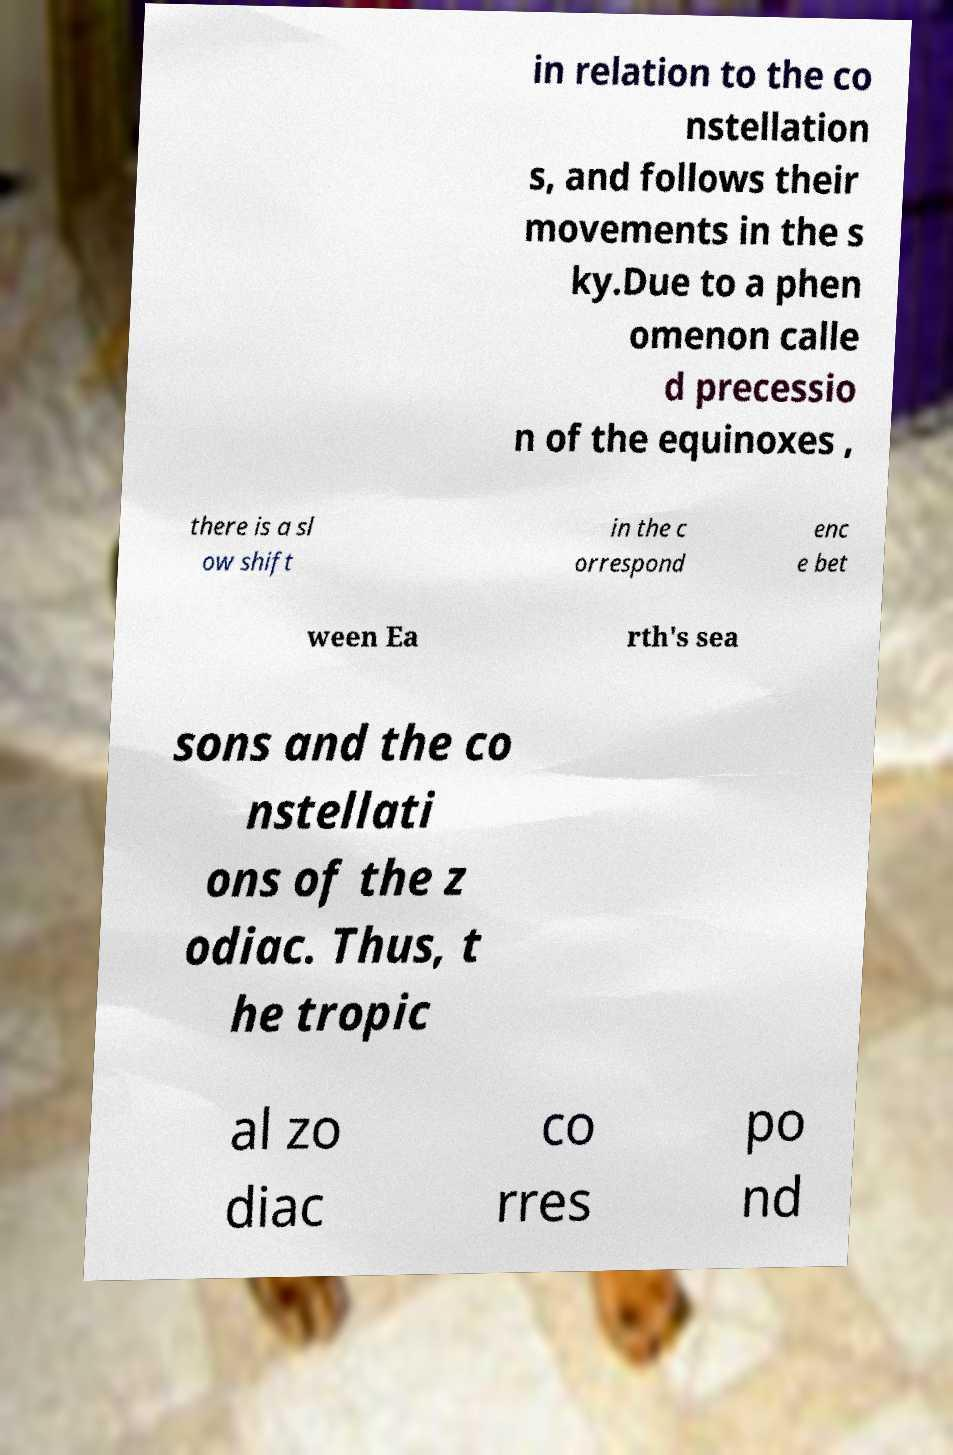Please read and relay the text visible in this image. What does it say? in relation to the co nstellation s, and follows their movements in the s ky.Due to a phen omenon calle d precessio n of the equinoxes , there is a sl ow shift in the c orrespond enc e bet ween Ea rth's sea sons and the co nstellati ons of the z odiac. Thus, t he tropic al zo diac co rres po nd 